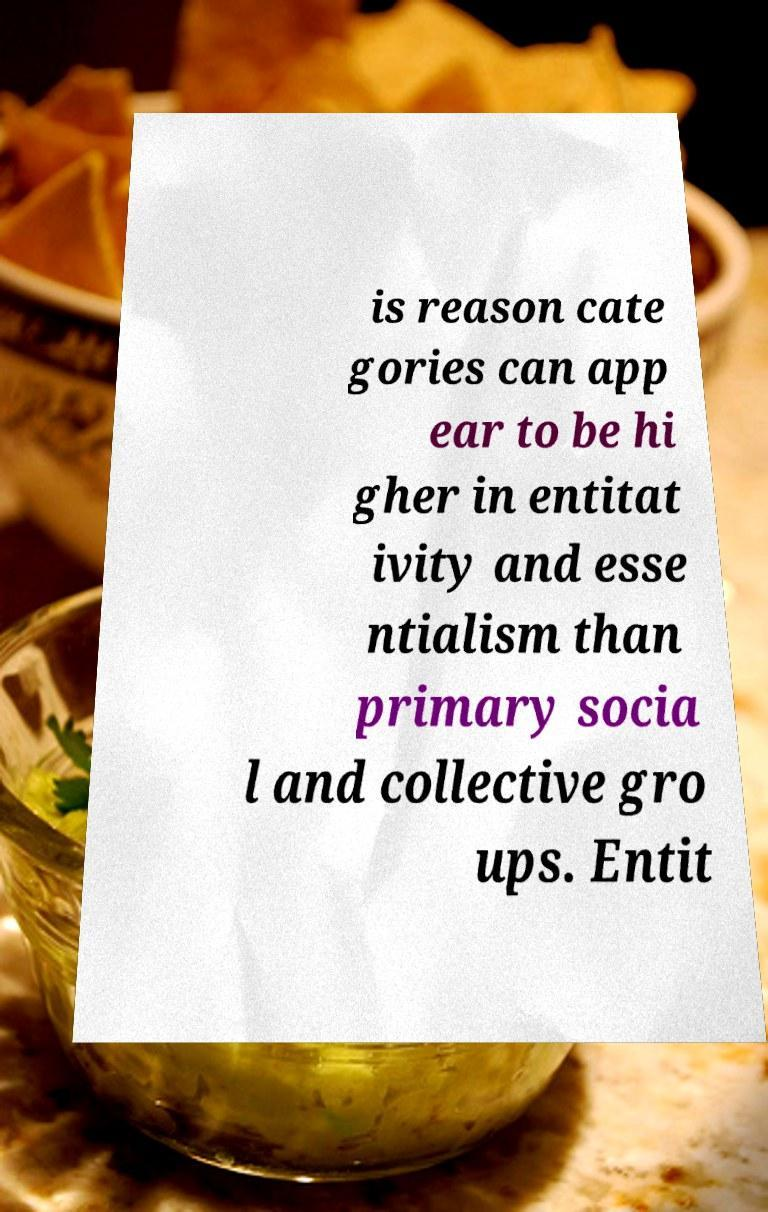Please read and relay the text visible in this image. What does it say? is reason cate gories can app ear to be hi gher in entitat ivity and esse ntialism than primary socia l and collective gro ups. Entit 